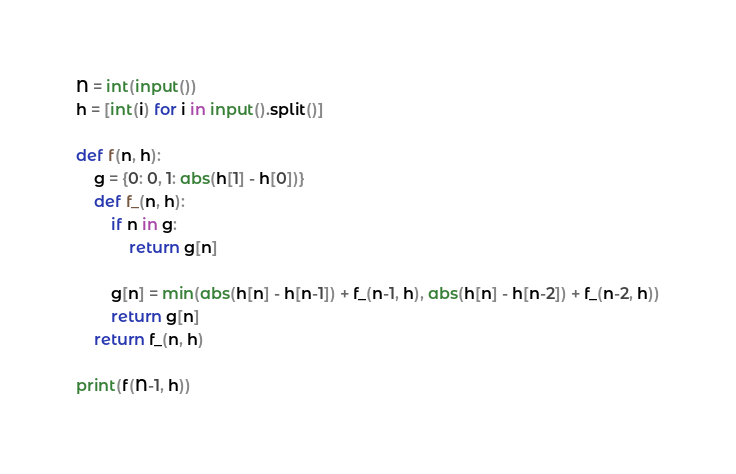<code> <loc_0><loc_0><loc_500><loc_500><_Python_>N = int(input())
h = [int(i) for i in input().split()]

def f(n, h):
    g = {0: 0, 1: abs(h[1] - h[0])}
    def f_(n, h):
        if n in g:
            return g[n]

        g[n] = min(abs(h[n] - h[n-1]) + f_(n-1, h), abs(h[n] - h[n-2]) + f_(n-2, h))
        return g[n]
    return f_(n, h)

print(f(N-1, h))

</code> 